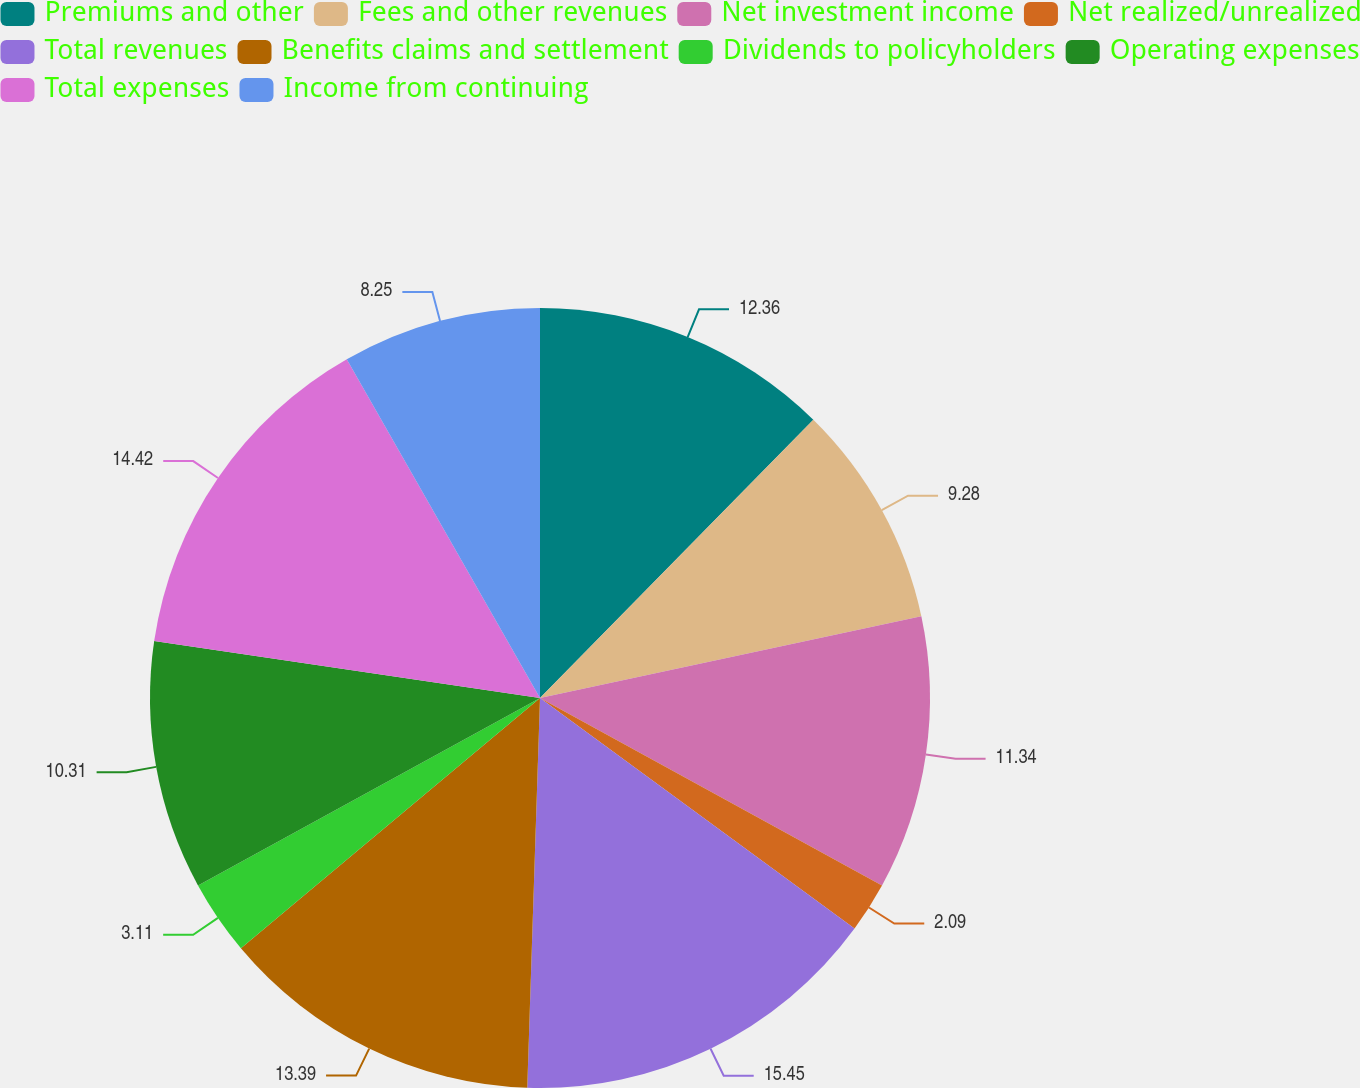Convert chart. <chart><loc_0><loc_0><loc_500><loc_500><pie_chart><fcel>Premiums and other<fcel>Fees and other revenues<fcel>Net investment income<fcel>Net realized/unrealized<fcel>Total revenues<fcel>Benefits claims and settlement<fcel>Dividends to policyholders<fcel>Operating expenses<fcel>Total expenses<fcel>Income from continuing<nl><fcel>12.36%<fcel>9.28%<fcel>11.34%<fcel>2.09%<fcel>15.45%<fcel>13.39%<fcel>3.11%<fcel>10.31%<fcel>14.42%<fcel>8.25%<nl></chart> 